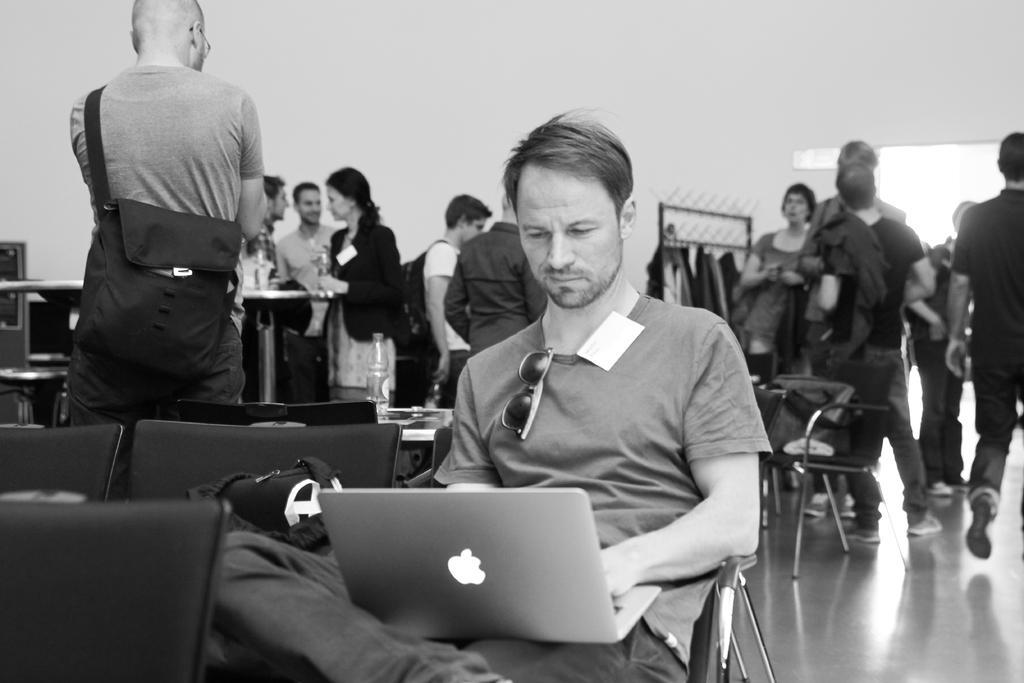Can you describe this image briefly? In the center, there is a person sitting and working with the laptop. In the background, there are group of people walking, some of them are standing, clothes, chairs, a bottle on the table and some other materials. 